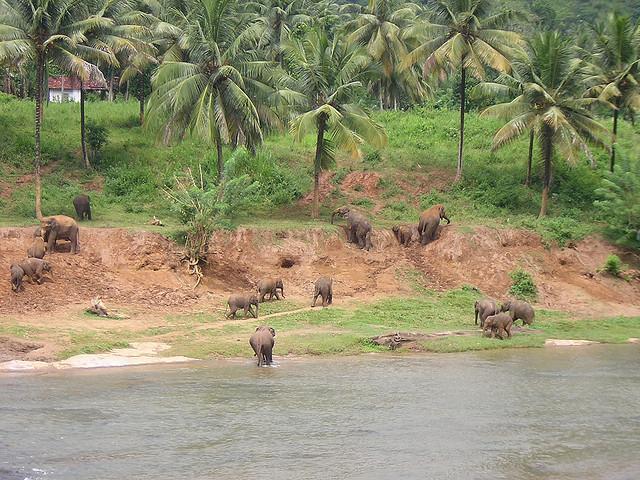What is a unique feature of these animals?
Choose the right answer and clarify with the format: 'Answer: answer
Rationale: rationale.'
Options: Quills, gills, neck, trunk. Answer: trunk.
Rationale: The feature is a trunk. 